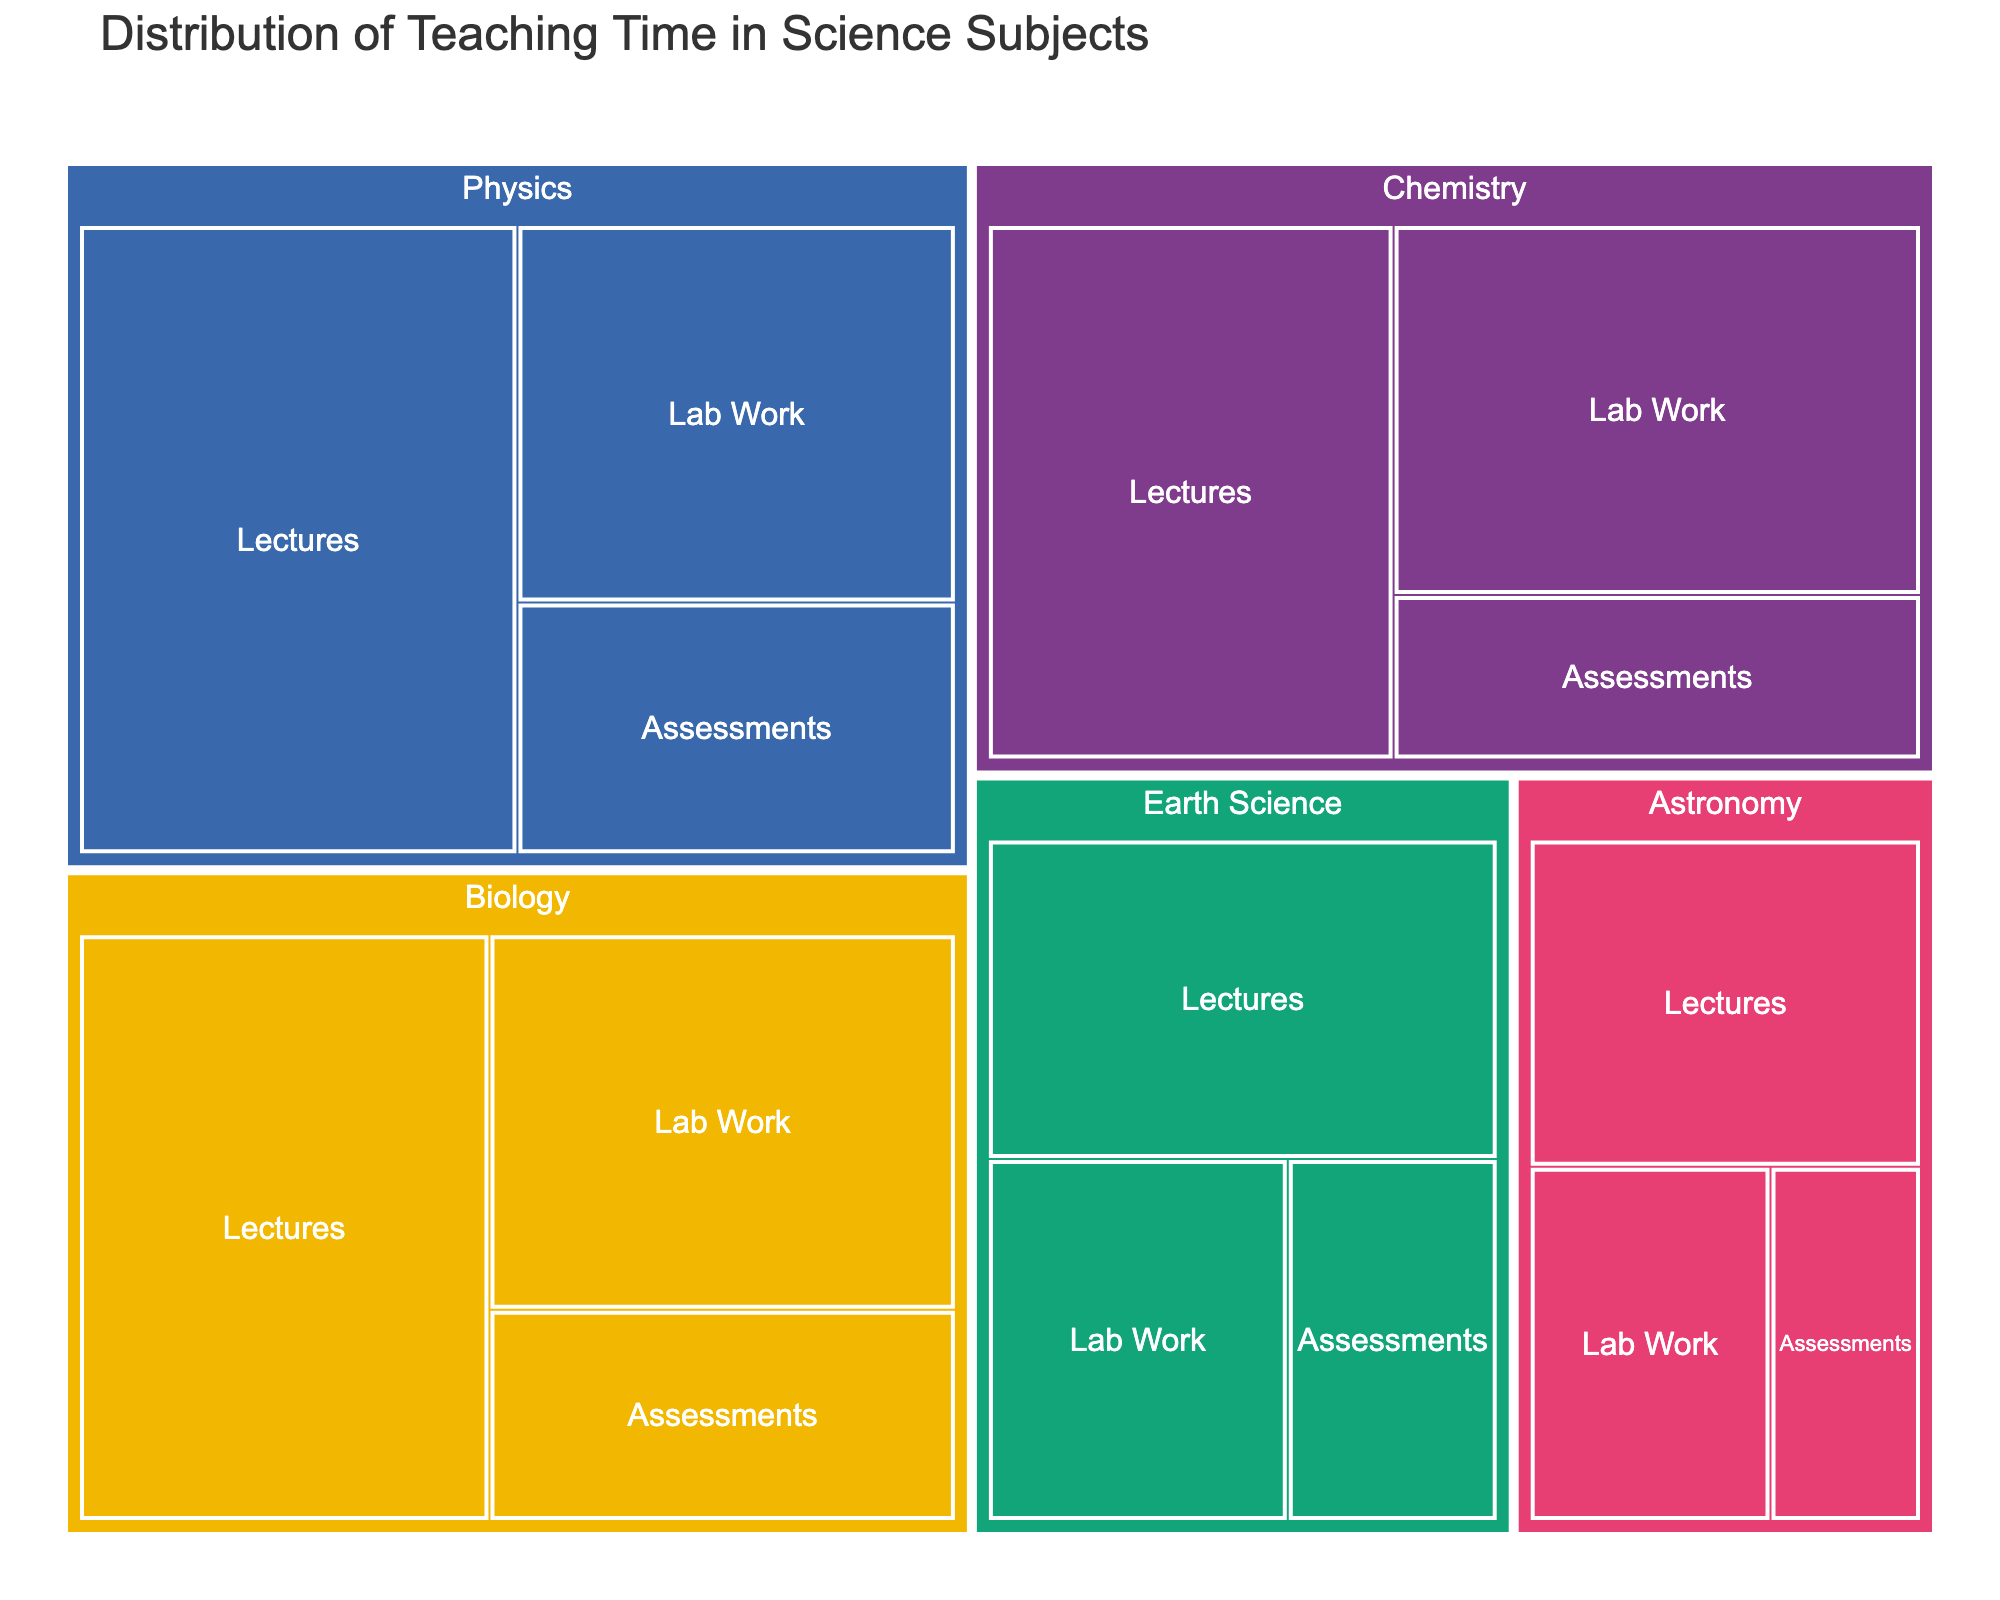what is the title of the treemap? The title of a treemap is usually displayed prominently at the top of the figure. In this case, the title is indicated in the code that generates the figure.
Answer: Distribution of Teaching Time in Science Subjects Which subject has the most lecture hours? By looking at the different sections for each subject, you can identify the largest section under the 'Lectures' category. Physics has 25 hours of lectures.
Answer: Physics How many hours are spent on Chemistry lab work compared to Earth Science lab work? Locate the lab work sections for Chemistry and Earth Science. Chemistry lab work takes 18 hours while Earth Science lab work takes 10 hours.
Answer: 18 hours for Chemistry, 10 hours for Earth Science What is the total time spent on assessments in all subjects? Sum the time allocated for assessments in all subjects: Physics (10), Chemistry (8), Biology (9), Earth Science (7), and Astronomy (5). 10 + 8 + 9 + 7 + 5 = 39 hours.
Answer: 39 hours What is the difference between the total time spent on Biology and Astronomy? Sum the time spent on each category (lectures, lab work, and assessments) for both Biology and Astronomy, and then find the difference. Biology: 22 (lectures) + 16 (lab work) + 9 (assessments) = 47 hours. Astronomy: 12 (lectures) + 8 (lab work) + 5 (assessments) = 25 hours. The difference is 47 - 25 = 22 hours.
Answer: 22 hours Which category has the least total time spent in all subjects combined? Sum the time for each category across all subjects and compare. Lectures: 25 (Physics) + 20 (Chemistry) + 22 (Biology) + 15 (Earth Science) + 12 (Astronomy) = 94 hours. Lab work: 15 (Physics) + 18 (Chemistry) + 16 (Biology) + 10 (Earth Science) + 8 (Astronomy) = 67 hours. Assessments: 10 (Physics) + 8 (Chemistry) + 9 (Biology) + 7 (Earth Science) + 5 (Astronomy) = 39 hours. Assessments have the least total time spent.
Answer: Assessments How much time is dedicated to Physics in total? Sum the time spent on each category for Physics: 25 (lectures) + 15 (lab work) + 10 (assessments) = 50 hours.
Answer: 50 hours Compare the total time spent on lectures for Biology and Chemistry. Which one has more? Locate the lecture sections for both subjects. Biology lectures take 22 hours and Chemistry lectures take 20 hours. 22 is greater than 20 so Biology has more lecture hours.
Answer: Biology Which subject has the smallest amount of lab work hours? Locate the 'Lab Work' sections for each subject and identify the smallest value. Astronomy has the least with 8 hours.
Answer: Astronomy If the lab work hours for Earth Science were increased by 3 hours, what would be the new total teaching time for Earth Science? Add 3 hours to the current lab work hours for Earth Science and then sum all the categories. Current lab work is 10 hours, so new lab work is 10 + 3 = 13 hours. Total Earth Science = 15 (lectures) + 13 (lab work) + 7 (assessments) = 35 hours.
Answer: 35 hours 